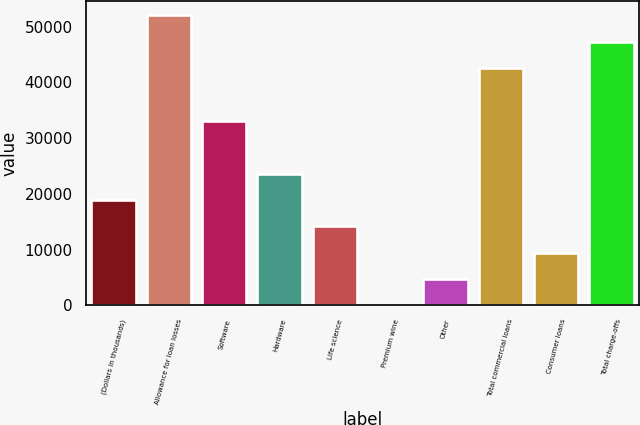Convert chart to OTSL. <chart><loc_0><loc_0><loc_500><loc_500><bar_chart><fcel>(Dollars in thousands)<fcel>Allowance for loan losses<fcel>Software<fcel>Hardware<fcel>Life science<fcel>Premium wine<fcel>Other<fcel>Total commercial loans<fcel>Consumer loans<fcel>Total charge-offs<nl><fcel>18919.6<fcel>52021.9<fcel>33106.3<fcel>23648.5<fcel>14190.7<fcel>4<fcel>4732.9<fcel>42564.1<fcel>9461.8<fcel>47293<nl></chart> 